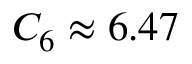Convert formula to latex. <formula><loc_0><loc_0><loc_500><loc_500>C _ { 6 } \approx 6 . 4 7</formula> 